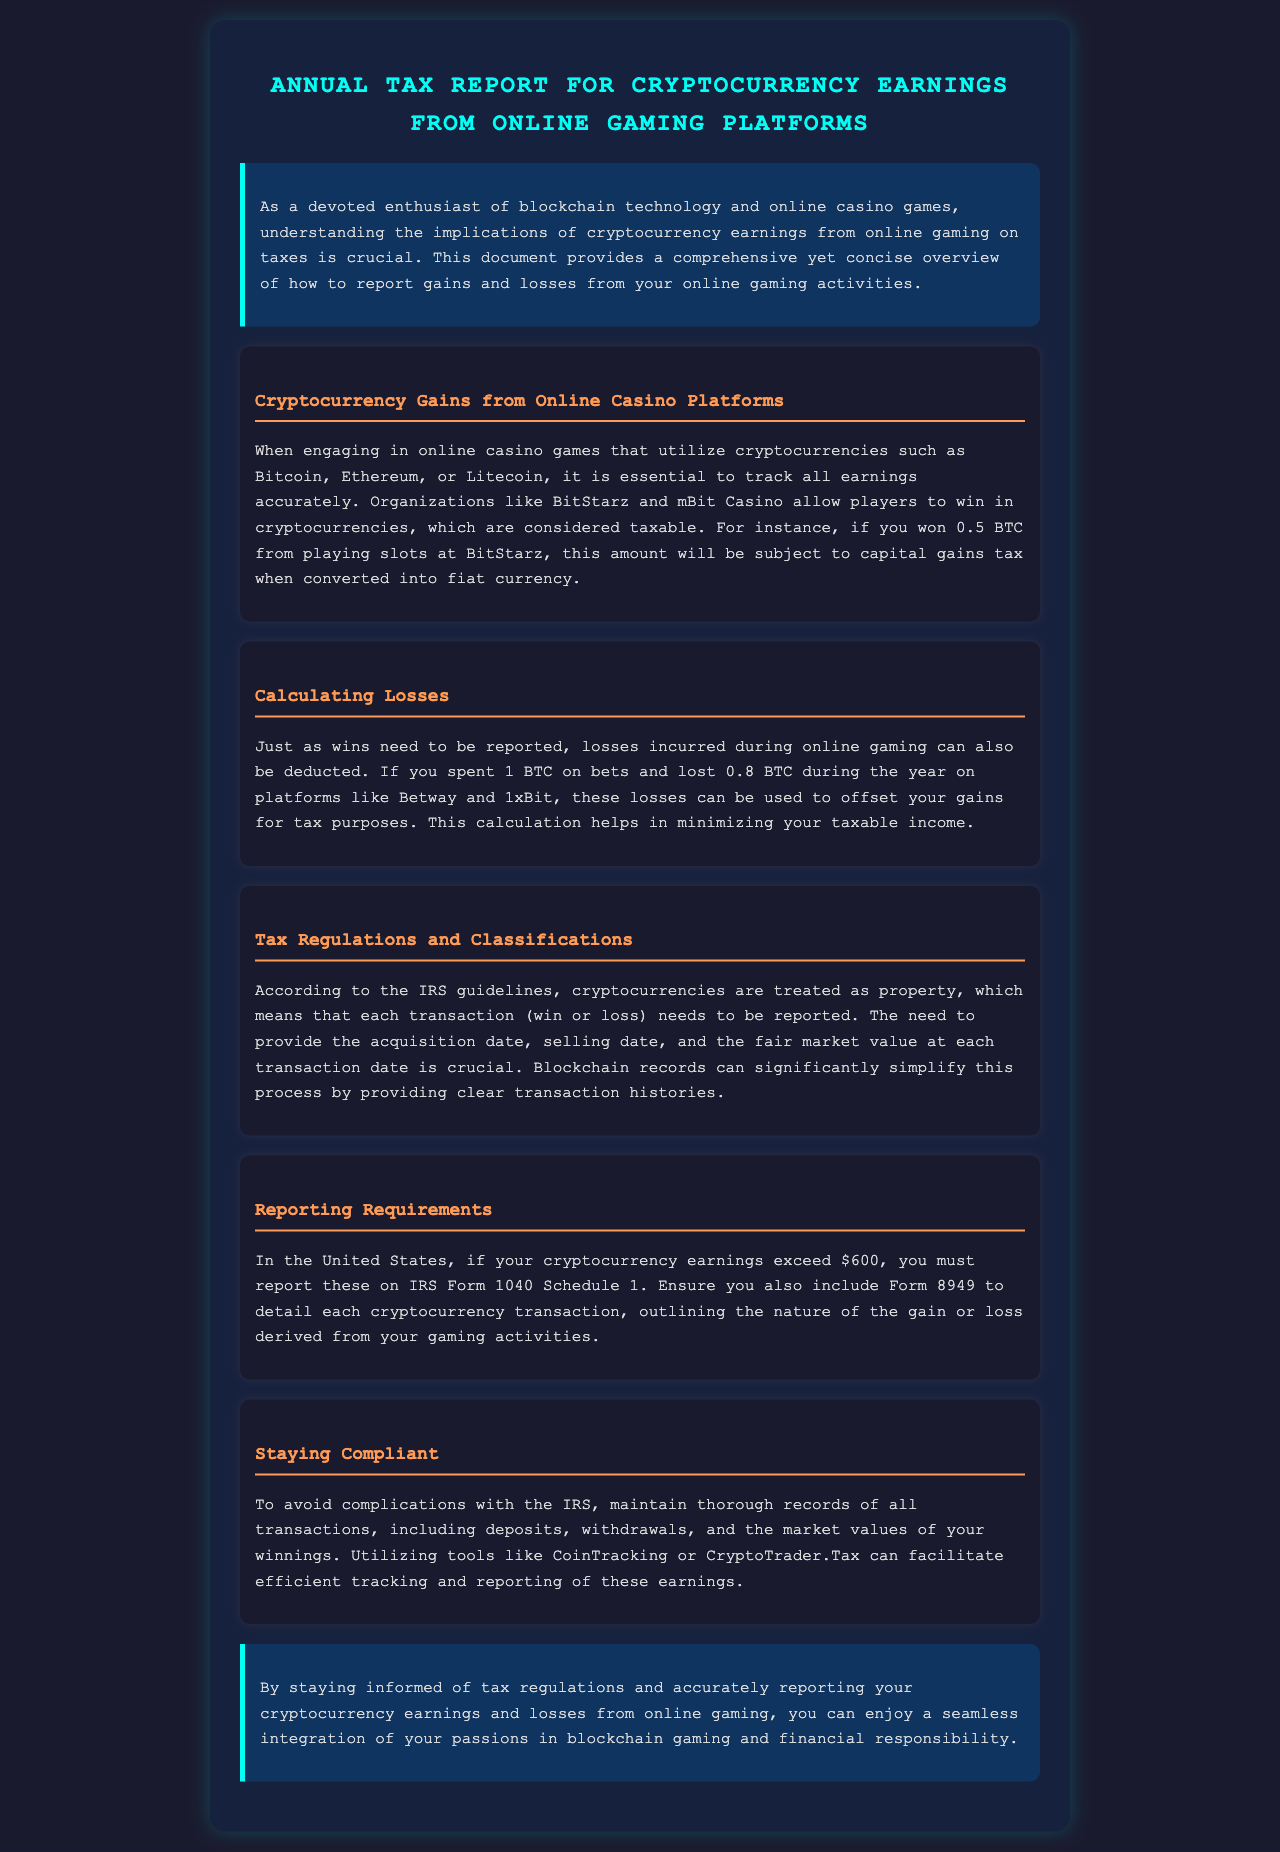What is the topic of the document? The document is titled "Annual Tax Report for Cryptocurrency Earnings from Online Gaming Platforms," indicating its focus on tax reporting for crypto earnings from gaming.
Answer: Annual Tax Report for Cryptocurrency Earnings from Online Gaming Platforms Which casinos are mentioned for earning cryptocurrency? The document refers to BitStarz and mBit Casino as platforms for winning cryptocurrencies.
Answer: BitStarz and mBit Casino What form must be reported if earnings exceed $600? The document states that earnings must be reported on IRS Form 1040 Schedule 1 if they exceed $600.
Answer: IRS Form 1040 Schedule 1 How much cryptocurrency spent leads to a deductible loss? The document mentions a scenario where spending 1 BTC and losing 0.8 BTC allows for a deductible loss.
Answer: 1 BTC What classification do cryptocurrencies fall under according to IRS guidelines? The document states that cryptocurrencies are classified as property by IRS guidelines.
Answer: Property Which tools are suggested for tracking cryptocurrency transactions? The document mentions tools like CoinTracking and CryptoTrader.Tax for efficient tracking and reporting.
Answer: CoinTracking or CryptoTrader.Tax What crucial information is required for each transaction? The document emphasizes the need to provide acquisition date, selling date, and fair market value for each transaction.
Answer: Acquisition date, selling date, fair market value What is the purpose of maintaining thorough records? The document explains that thorough record-keeping avoids complications with the IRS during reporting.
Answer: Avoid complications with the IRS 